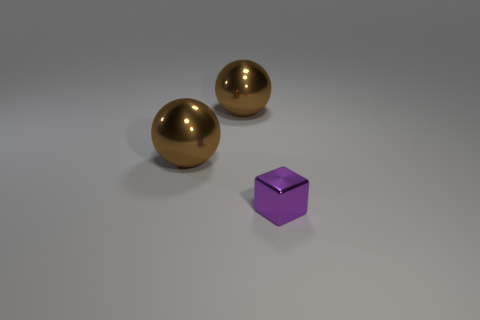Is there any other thing that has the same size as the purple object?
Keep it short and to the point. No. What number of other objects are there of the same color as the tiny metallic block?
Your answer should be very brief. 0. What number of cylinders are either shiny things or blue metallic things?
Provide a succinct answer. 0. Are there fewer purple objects in front of the purple shiny block than brown metallic objects?
Your answer should be compact. Yes. What number of other things are there of the same material as the purple thing
Keep it short and to the point. 2. How many objects are metallic objects behind the purple shiny cube or small green blocks?
Your answer should be very brief. 2. How many things are either metallic things behind the small block or things on the left side of the small shiny cube?
Ensure brevity in your answer.  2. Are there more brown metallic balls that are behind the tiny metallic object than tiny shiny blocks?
Provide a succinct answer. Yes. How many things are the same size as the metal cube?
Ensure brevity in your answer.  0. Are there any large balls behind the tiny purple thing?
Your response must be concise. Yes. 